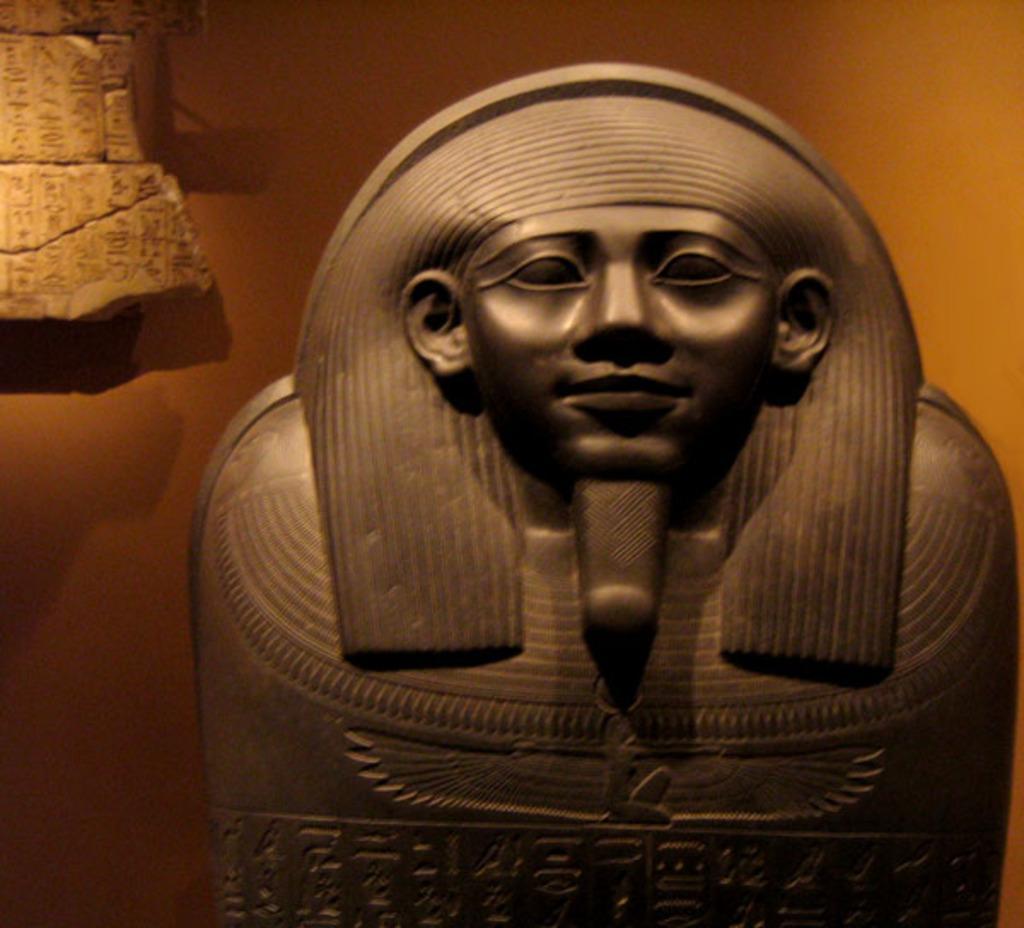Can you describe this image briefly? In the center of the image there is a sculpture. In the background there is a wall. 